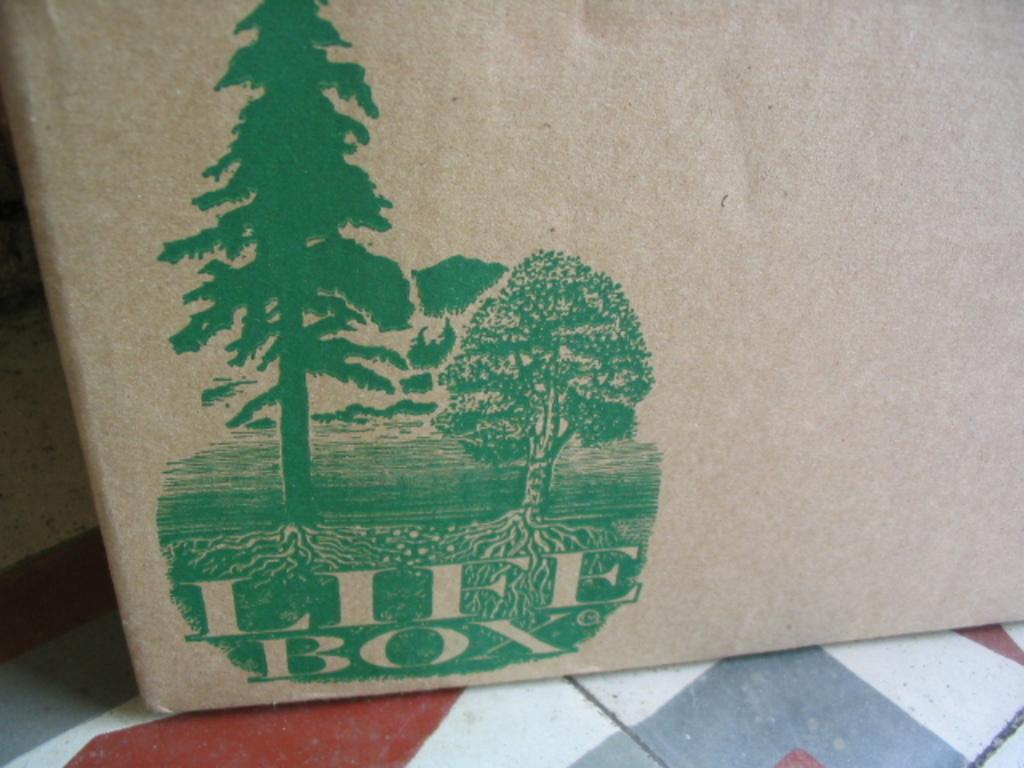What's the name of this box?
Make the answer very short. Life box. What letter appears after the brand name life box?
Provide a short and direct response. C. 